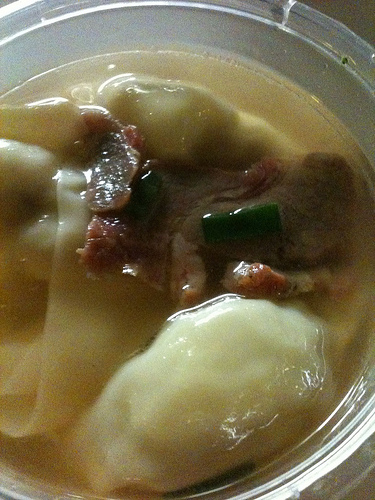<image>
Can you confirm if the potato is in the sauce? Yes. The potato is contained within or inside the sauce, showing a containment relationship. 